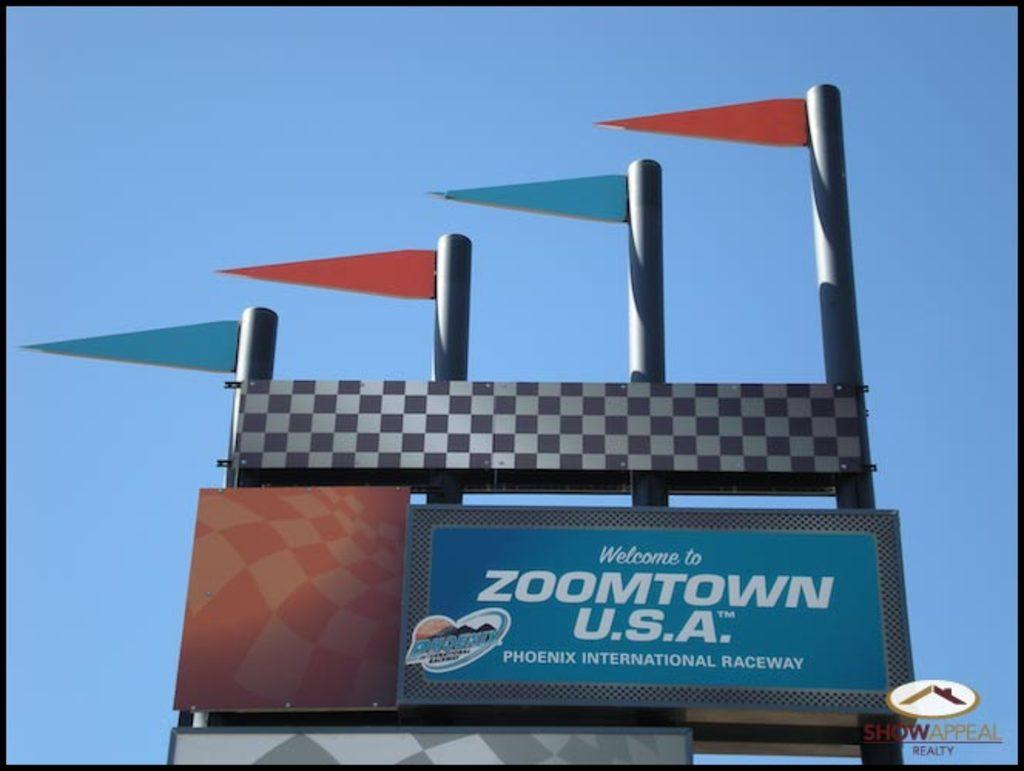<image>
Summarize the visual content of the image. A sign that reads welcome to Zoomtown U.S.A. has four flags on top of it. 